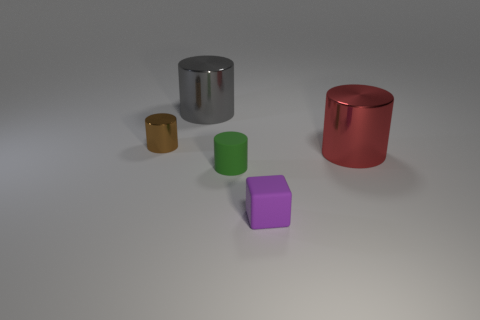What is the color of the other tiny rubber object that is the same shape as the tiny brown object?
Ensure brevity in your answer.  Green. What size is the red object?
Your response must be concise. Large. What number of other brown metal cylinders have the same size as the brown metal cylinder?
Offer a terse response. 0. Is the color of the tiny block the same as the small matte cylinder?
Provide a short and direct response. No. Are the tiny purple block in front of the brown cylinder and the large cylinder right of the small purple matte cube made of the same material?
Offer a very short reply. No. Are there more big cylinders than purple rubber cubes?
Your response must be concise. Yes. Is there anything else that has the same color as the small shiny cylinder?
Offer a terse response. No. Is the material of the large red object the same as the small green object?
Your response must be concise. No. Are there fewer large green metallic things than purple matte things?
Give a very brief answer. Yes. Does the big gray thing have the same shape as the big red thing?
Offer a terse response. Yes. 